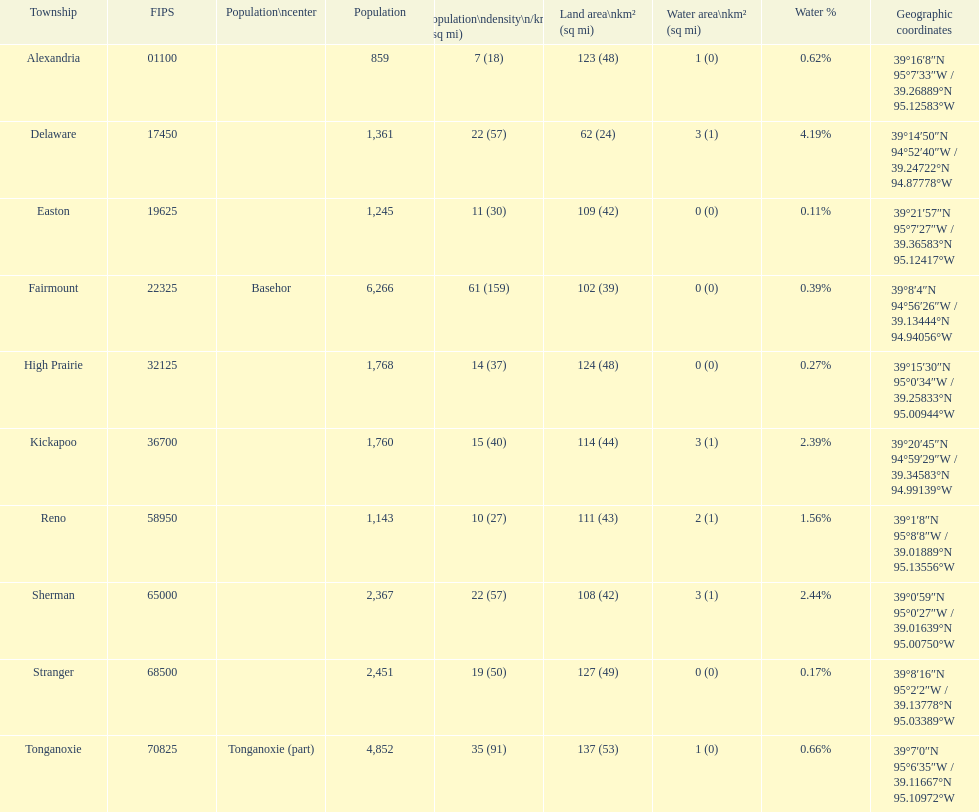Could you parse the entire table? {'header': ['Township', 'FIPS', 'Population\\ncenter', 'Population', 'Population\\ndensity\\n/km² (/sq\xa0mi)', 'Land area\\nkm² (sq\xa0mi)', 'Water area\\nkm² (sq\xa0mi)', 'Water\xa0%', 'Geographic coordinates'], 'rows': [['Alexandria', '01100', '', '859', '7 (18)', '123 (48)', '1 (0)', '0.62%', '39°16′8″N 95°7′33″W\ufeff / \ufeff39.26889°N 95.12583°W'], ['Delaware', '17450', '', '1,361', '22 (57)', '62 (24)', '3 (1)', '4.19%', '39°14′50″N 94°52′40″W\ufeff / \ufeff39.24722°N 94.87778°W'], ['Easton', '19625', '', '1,245', '11 (30)', '109 (42)', '0 (0)', '0.11%', '39°21′57″N 95°7′27″W\ufeff / \ufeff39.36583°N 95.12417°W'], ['Fairmount', '22325', 'Basehor', '6,266', '61 (159)', '102 (39)', '0 (0)', '0.39%', '39°8′4″N 94°56′26″W\ufeff / \ufeff39.13444°N 94.94056°W'], ['High Prairie', '32125', '', '1,768', '14 (37)', '124 (48)', '0 (0)', '0.27%', '39°15′30″N 95°0′34″W\ufeff / \ufeff39.25833°N 95.00944°W'], ['Kickapoo', '36700', '', '1,760', '15 (40)', '114 (44)', '3 (1)', '2.39%', '39°20′45″N 94°59′29″W\ufeff / \ufeff39.34583°N 94.99139°W'], ['Reno', '58950', '', '1,143', '10 (27)', '111 (43)', '2 (1)', '1.56%', '39°1′8″N 95°8′8″W\ufeff / \ufeff39.01889°N 95.13556°W'], ['Sherman', '65000', '', '2,367', '22 (57)', '108 (42)', '3 (1)', '2.44%', '39°0′59″N 95°0′27″W\ufeff / \ufeff39.01639°N 95.00750°W'], ['Stranger', '68500', '', '2,451', '19 (50)', '127 (49)', '0 (0)', '0.17%', '39°8′16″N 95°2′2″W\ufeff / \ufeff39.13778°N 95.03389°W'], ['Tonganoxie', '70825', 'Tonganoxie (part)', '4,852', '35 (91)', '137 (53)', '1 (0)', '0.66%', '39°7′0″N 95°6′35″W\ufeff / \ufeff39.11667°N 95.10972°W']]} What township has the largest population? Fairmount. 